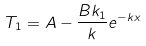Convert formula to latex. <formula><loc_0><loc_0><loc_500><loc_500>T _ { 1 } = A - \frac { B k _ { 1 } } { k } e ^ { - k x }</formula> 